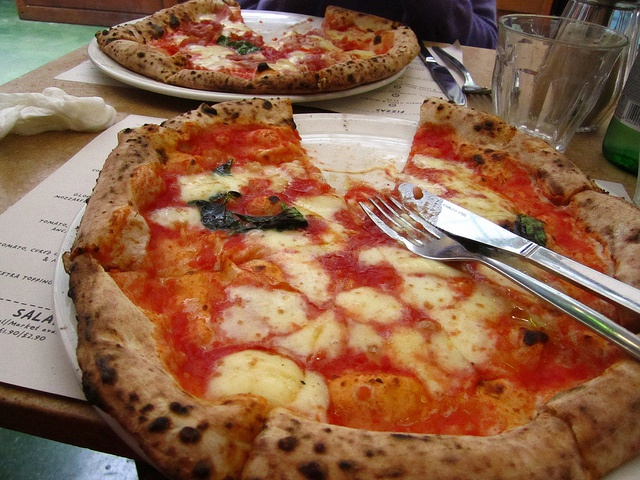Describe the objects in this image and their specific colors. I can see pizza in teal, brown, gray, and maroon tones, pizza in teal, maroon, and brown tones, cup in teal, gray, maroon, and black tones, fork in teal, gray, darkgray, and lightgray tones, and knife in teal, lightgray, and darkgray tones in this image. 